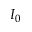Convert formula to latex. <formula><loc_0><loc_0><loc_500><loc_500>I _ { 0 }</formula> 